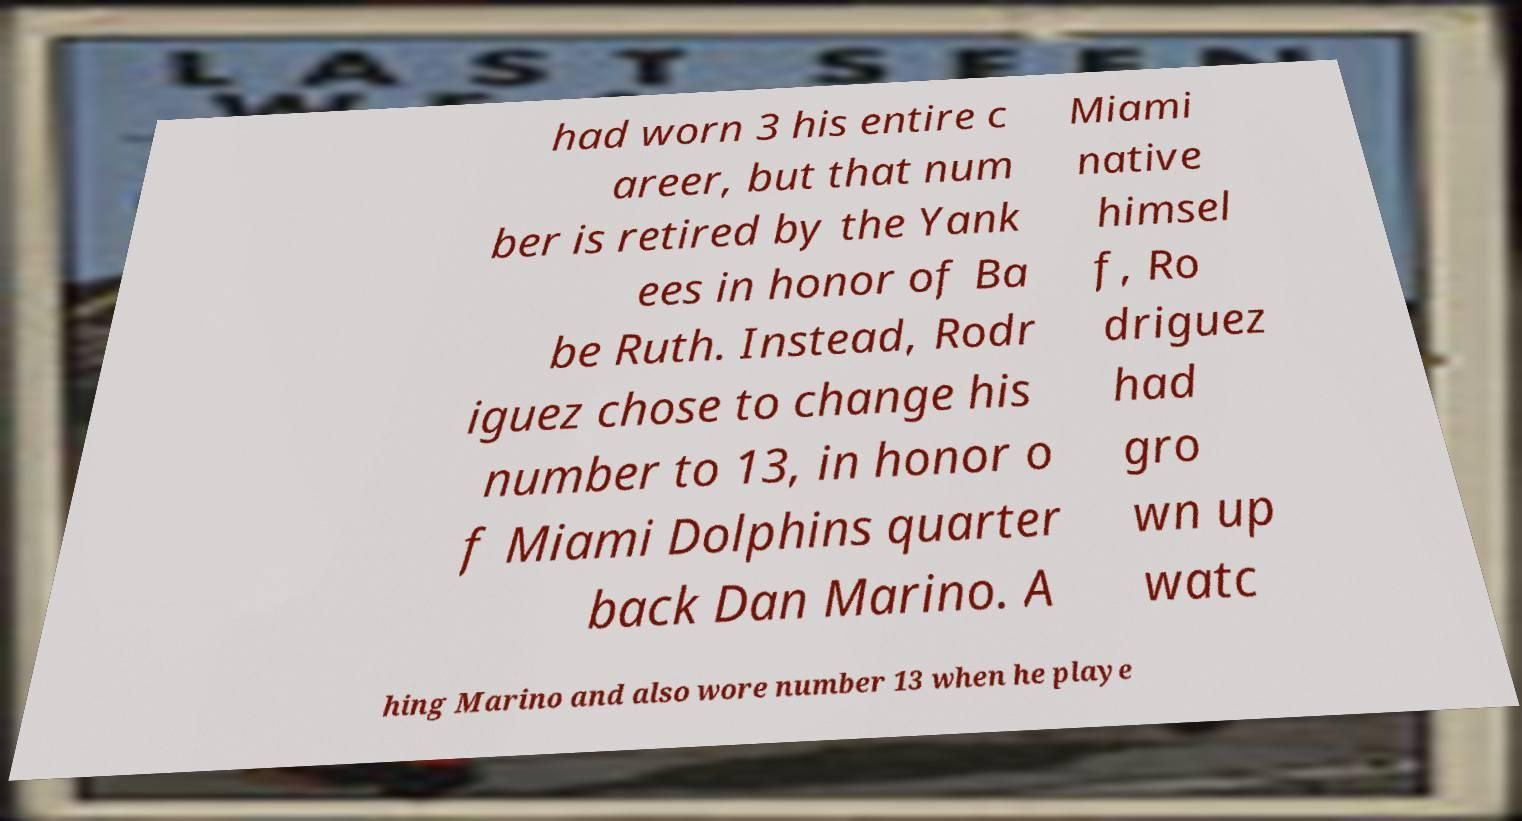Can you read and provide the text displayed in the image?This photo seems to have some interesting text. Can you extract and type it out for me? had worn 3 his entire c areer, but that num ber is retired by the Yank ees in honor of Ba be Ruth. Instead, Rodr iguez chose to change his number to 13, in honor o f Miami Dolphins quarter back Dan Marino. A Miami native himsel f, Ro driguez had gro wn up watc hing Marino and also wore number 13 when he playe 